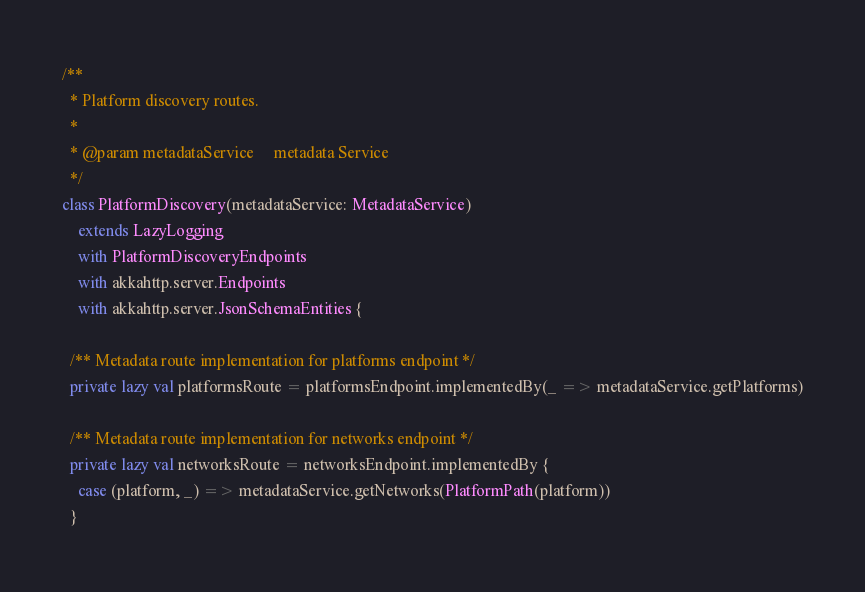Convert code to text. <code><loc_0><loc_0><loc_500><loc_500><_Scala_>/**
  * Platform discovery routes.
  *
  * @param metadataService     metadata Service
  */
class PlatformDiscovery(metadataService: MetadataService)
    extends LazyLogging
    with PlatformDiscoveryEndpoints
    with akkahttp.server.Endpoints
    with akkahttp.server.JsonSchemaEntities {

  /** Metadata route implementation for platforms endpoint */
  private lazy val platformsRoute = platformsEndpoint.implementedBy(_ => metadataService.getPlatforms)

  /** Metadata route implementation for networks endpoint */
  private lazy val networksRoute = networksEndpoint.implementedBy {
    case (platform, _) => metadataService.getNetworks(PlatformPath(platform))
  }
</code> 